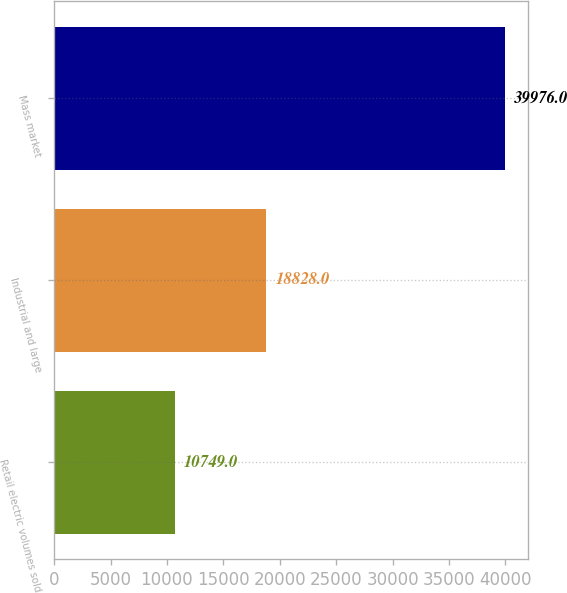<chart> <loc_0><loc_0><loc_500><loc_500><bar_chart><fcel>Retail electric volumes sold<fcel>Industrial and large<fcel>Mass market<nl><fcel>10749<fcel>18828<fcel>39976<nl></chart> 